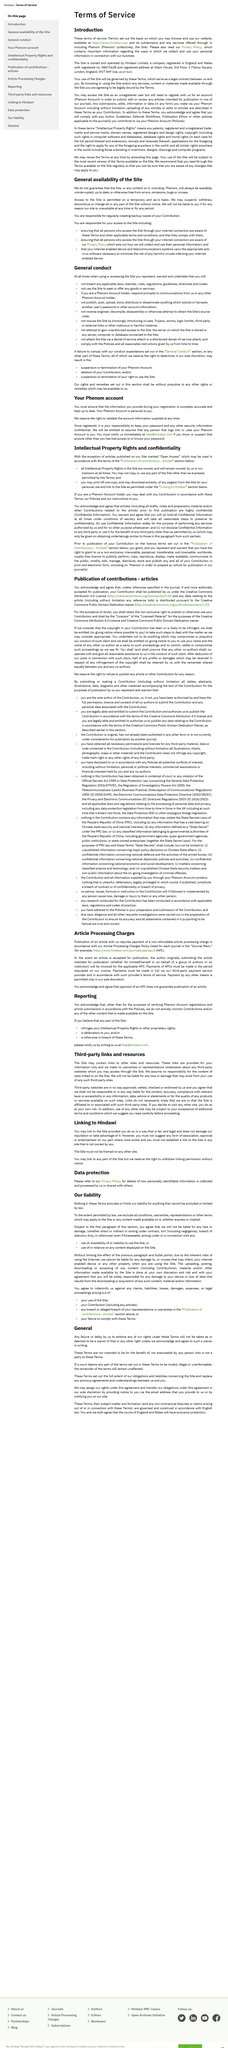Highlight a few significant elements in this photo. If the copyright in your Contribution has been or is likely to be infringed, you will be entitled (provided that you have given notice if necessary) to allow the copyright holder to take appropriate steps to deal with the matter, however they see fit. Articles that have been editorially accepted for publication will be published under the Creative Commons Attribution 4.0 License. These terms shall not extend to, nor benefit, nor be exercisable by, any person who is not a party to these terms. Said parties shall be notified by email. If any part of the terms is deemed invalid, illegal, or unenforceable by a court, the remainder of the terms will remain unaffected. Hindawi Limited was the owner and operator of the Site. 